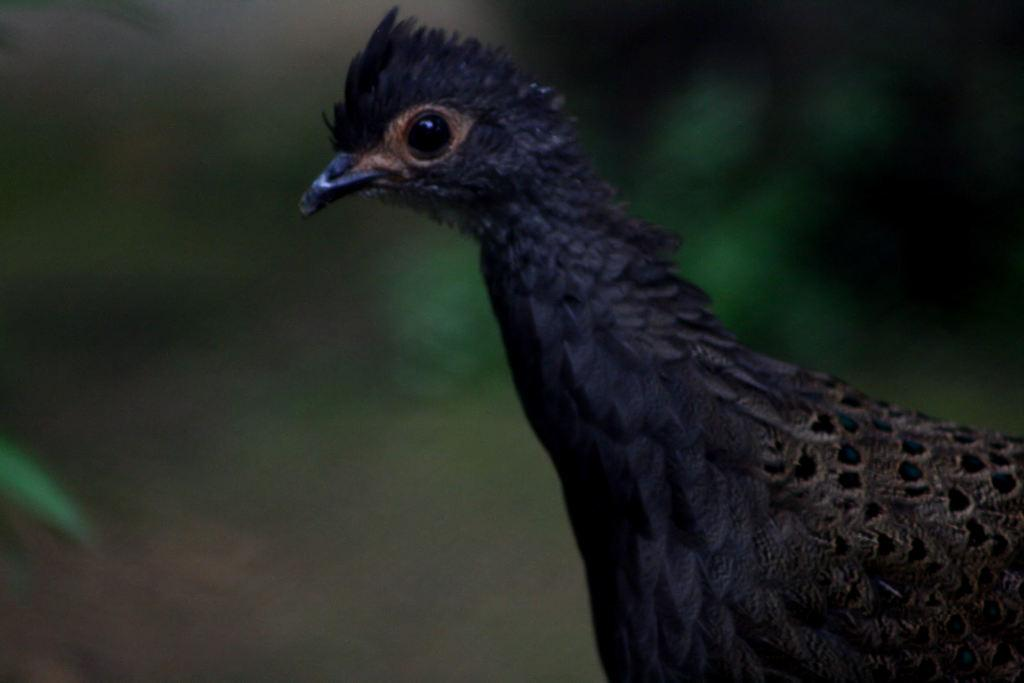What type of animal can be seen in the image? There is a bird in the image. What type of pancake is the bird eating in the image? There is no pancake present in the image, and the bird is not shown eating anything. 